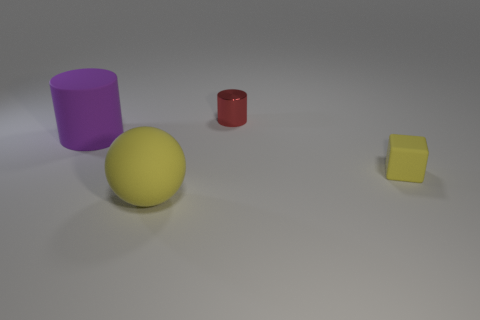Add 3 small objects. How many objects exist? 7 Subtract all cubes. How many objects are left? 3 Subtract all big purple matte cylinders. Subtract all big purple matte cylinders. How many objects are left? 2 Add 2 big purple cylinders. How many big purple cylinders are left? 3 Add 1 small matte objects. How many small matte objects exist? 2 Subtract 0 cyan cylinders. How many objects are left? 4 